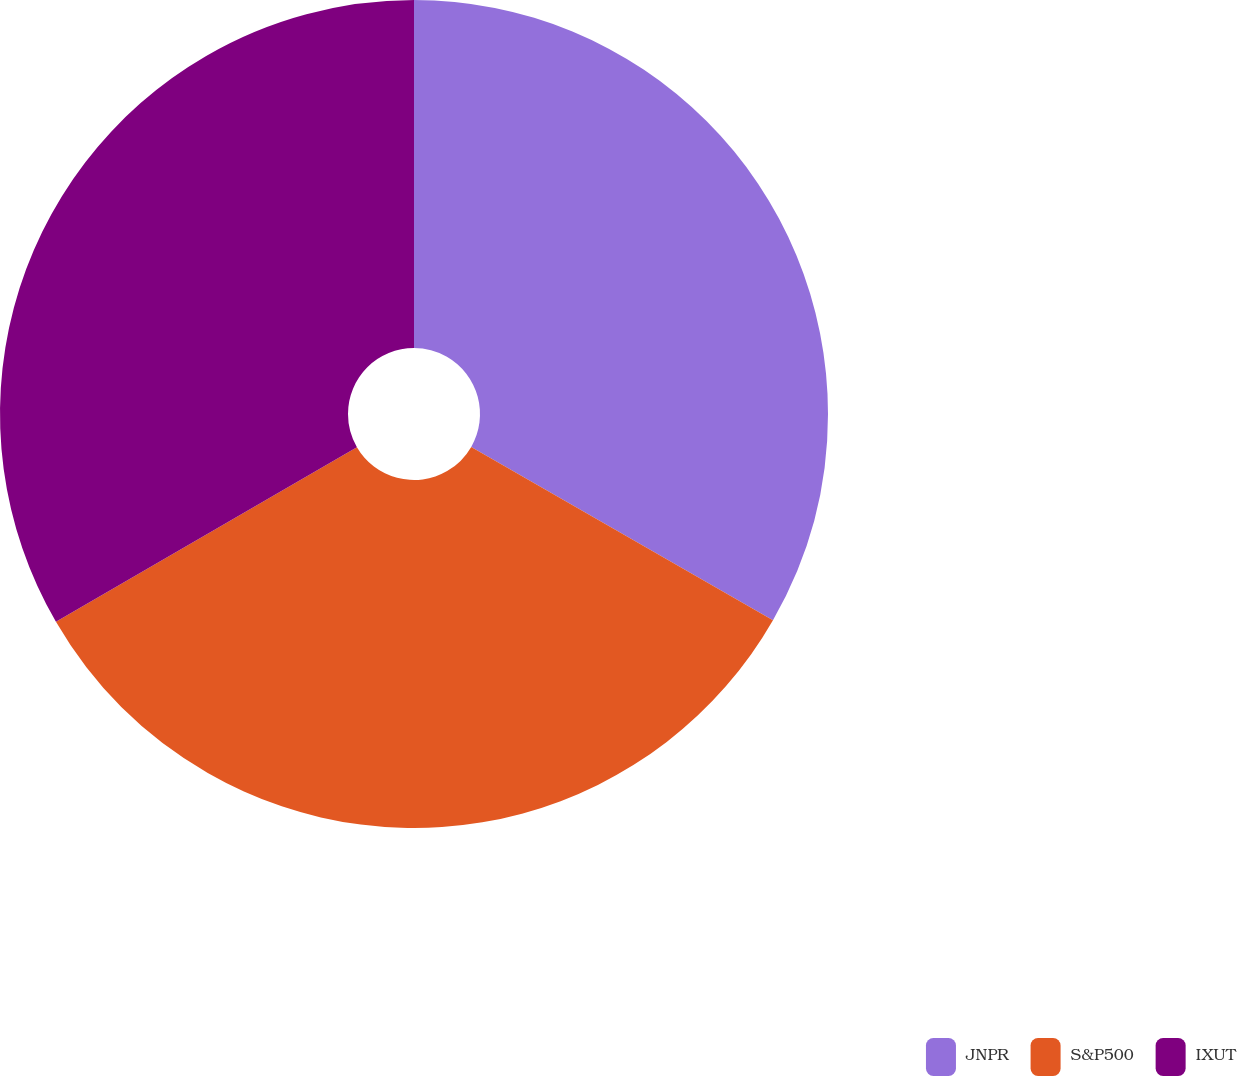<chart> <loc_0><loc_0><loc_500><loc_500><pie_chart><fcel>JNPR<fcel>S&P500<fcel>IXUT<nl><fcel>33.3%<fcel>33.33%<fcel>33.37%<nl></chart> 